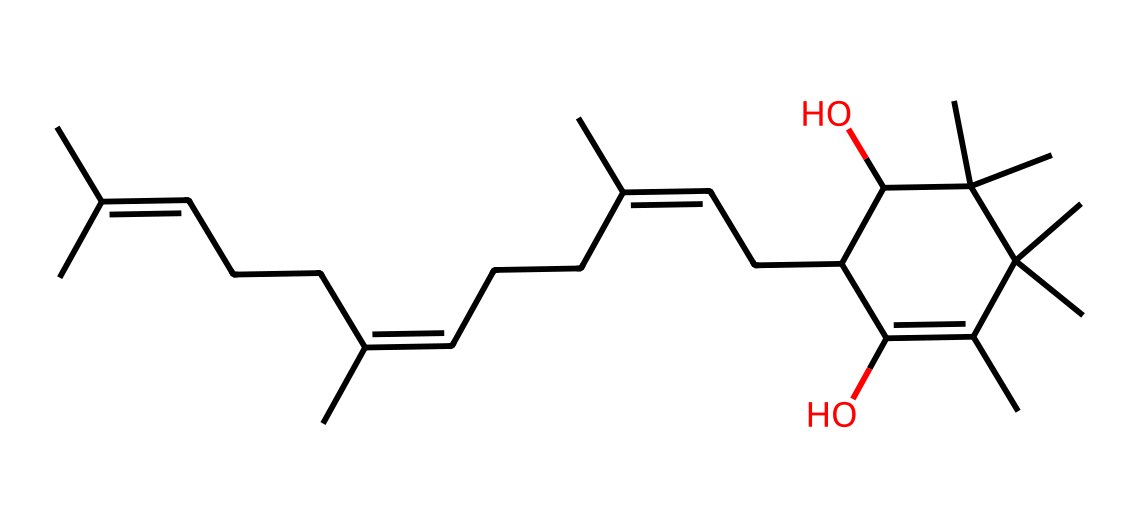what is the primary functional group in this structure? The chemical structure contains multiple hydroxyl (–OH) groups, which indicates the presence of alcohol functional groups. The SMILES representation shows two instances of "O" connected to carbon atoms, signifying these alcohol functional groups.
Answer: hydroxyl how many carbon atoms are present in this molecule? To find the number of carbon atoms, we can count the 'C' characters in the SMILES representation. Upon counting, there are a total of 27 carbon atoms in the structure.
Answer: 27 what is the degree of unsaturation in this molecule? The degree of unsaturation can be calculated using the formula: (2C + 2 + N - H - X)/2. In this case, C=27, H can be inferred from the structure, and there are no nitrogen or halogens, resulting in a high degree indicating multiple rings or double bonds. The molecule features multiple double bonds as inferred from the "C=C" notations in the SMILES. Such characteristics indicate a degree of unsaturation greater than 4.
Answer: greater than 4 what type of vitamin is represented in this molecule? The molecule structure corresponds to vitamin E, which is primarily known for its antioxidant properties found in green leafy vegetables, including taro leaves. The recognizable structure with its conjugated double bonds aligns with that of tocopherols, the form of vitamin E.
Answer: vitamin E how many double bonds are present in this structure? The presence of "C=C" in the SMILES indicates double bonds. Each sequence of "C=C" represents one double bond. There are four visible "C=C" pairs when counting from the structure, confirming the total number of double bonds.
Answer: 4 which part of this chemical structure contributes to its antioxidant properties? The antioxidant properties of vitamin E are primarily attributed to the hydroxyl (–OH) groups, as these groups can donate hydrogen atoms and neutralize free radicals. There are two –OH groups present in this molecule, enhancing its antioxidant capability.
Answer: hydroxyl groups what is the molecular formula for this compound? The molecular formula can be determined from the count of carbon, hydrogen, and oxygen atoms in the structure. For the given molecule, there are 27 carbons, 50 hydrogens, and 2 oxygens, resulting in the final molecular formula being C27H50O2.
Answer: C27H50O2 